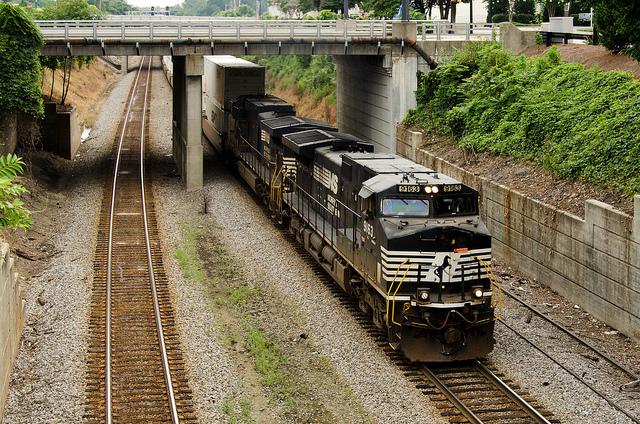What colors are the train?
Quick response, please. Black. Is the train crossing over the bridge?
Be succinct. No. Are there trains going in both directions?
Answer briefly. No. What color is the train engine?
Be succinct. Black. 